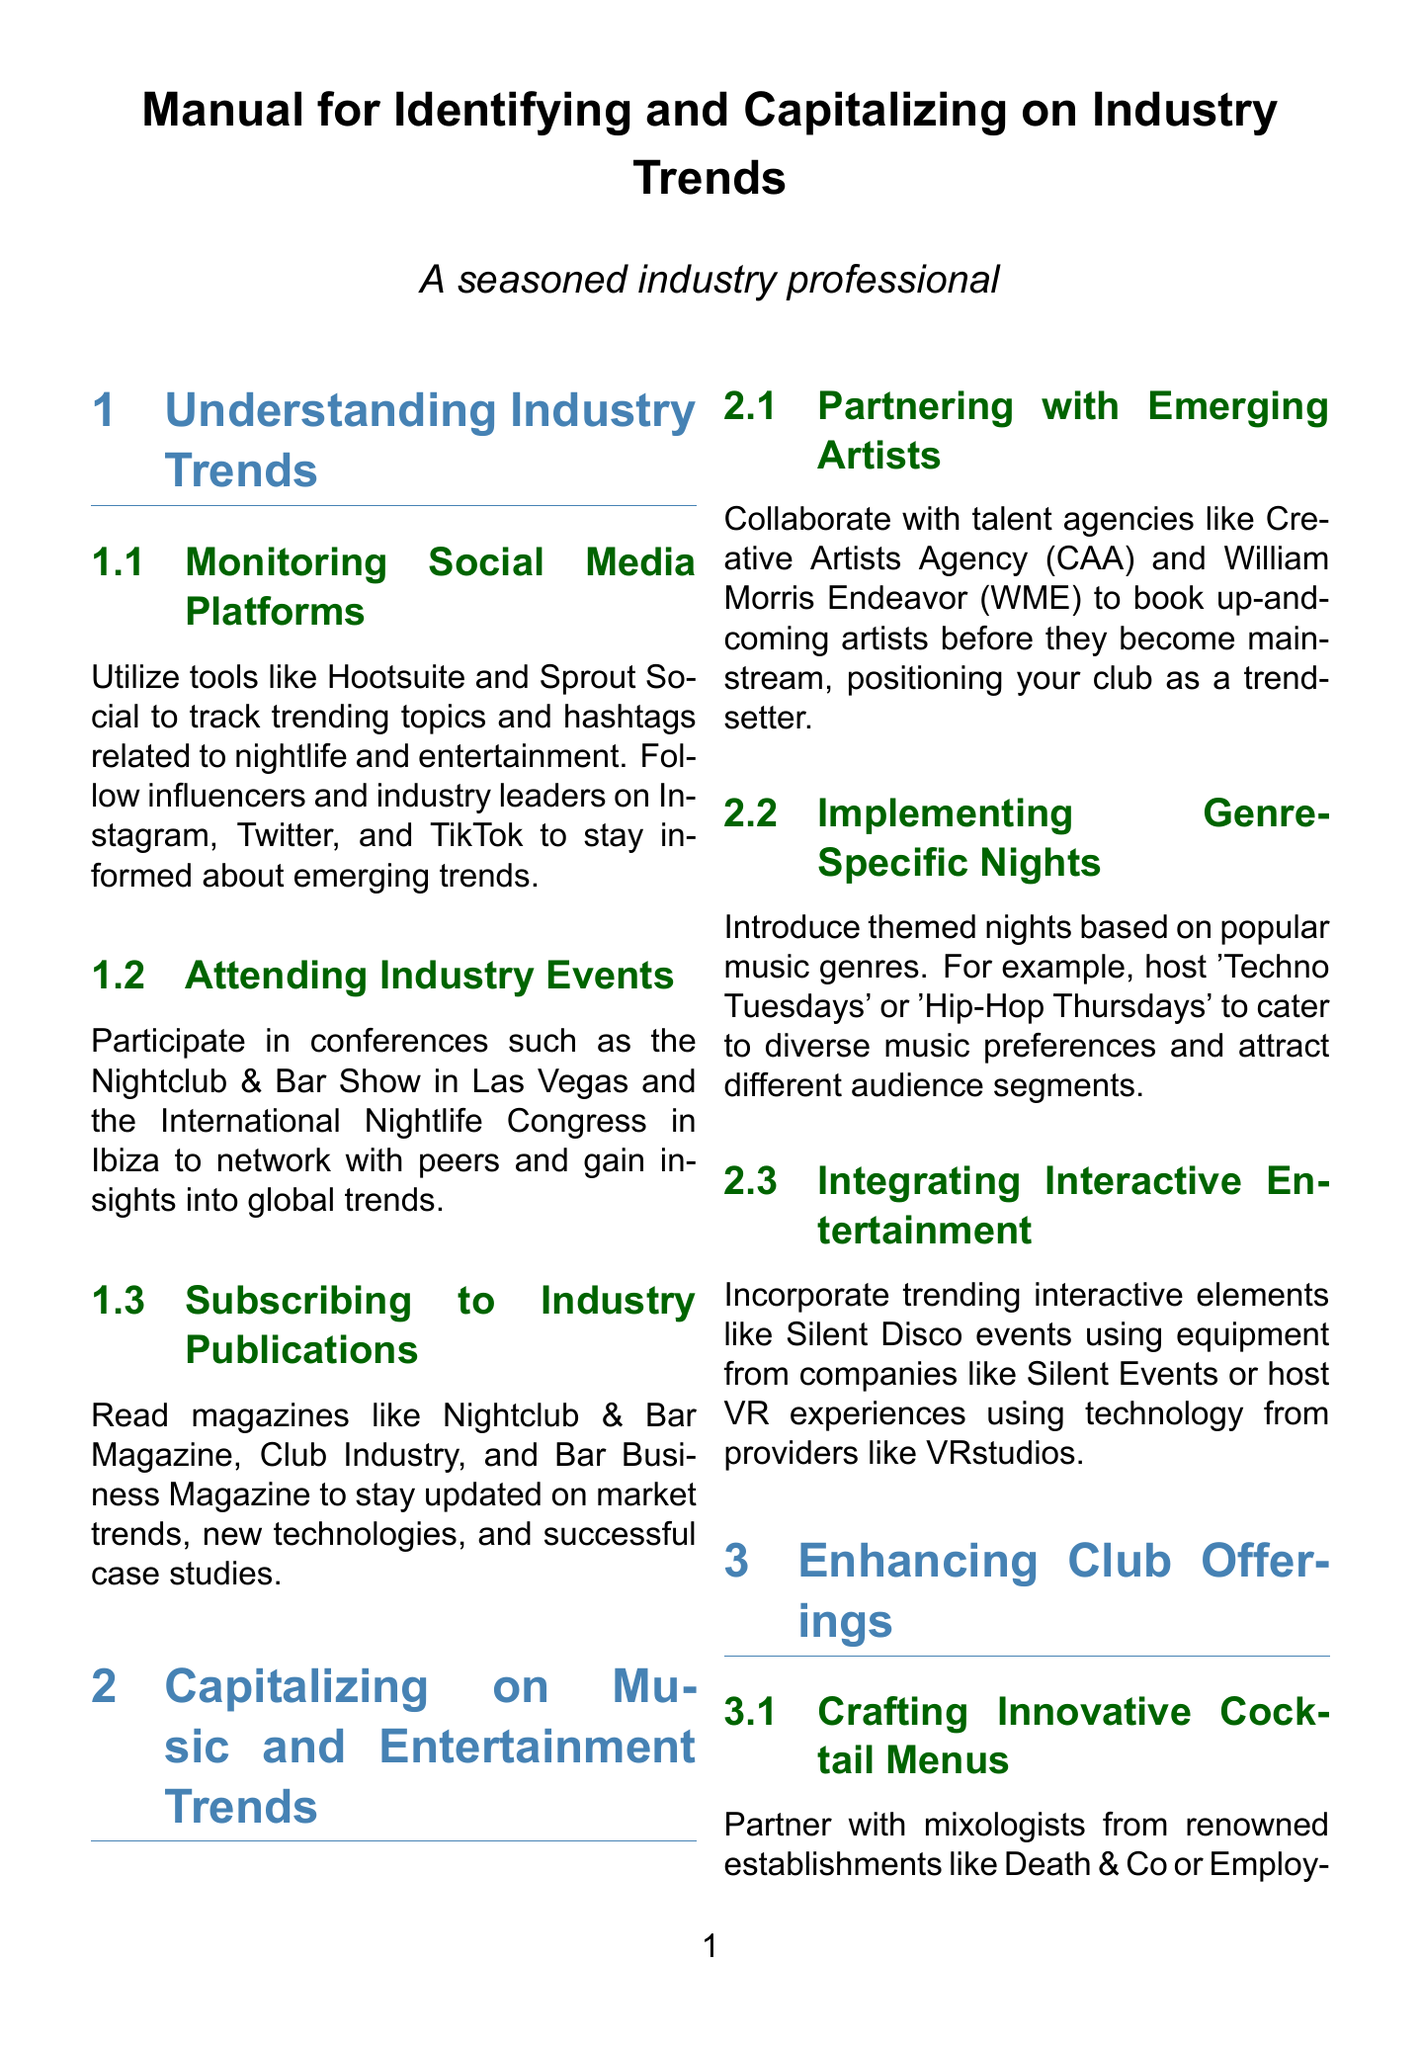What tools are suggested for monitoring social media trends? The manual suggests utilizing tools like Hootsuite and Sprout Social.
Answer: Hootsuite and Sprout Social What is one of the conferences mentioned for industry networking? The manual mentions the Nightclub & Bar Show in Las Vegas as one such conference.
Answer: Nightclub & Bar Show Which technology can be integrated for seamless payments? The manual recommends integrating RFID wristbands for this purpose.
Answer: RFID wristbands What is a recommended way to attract diverse clientele? The document states that hosting inclusive events can attract diverse clientele.
Answer: Hosting inclusive events Which marketing platform is suggested for creating targeted campaigns? The manual suggests using data-driven marketing platforms like Sprinklr or Salesforce Marketing Cloud.
Answer: Sprinklr or Salesforce Marketing Cloud What type of nights should be introduced to cater to diverse music preferences? The document recommends implementing genre-specific nights such as 'Techno Tuesdays' or 'Hip-Hop Thursdays'.
Answer: Genre-specific nights Which firms can be partnered with for organizing focus groups? Nielsen or Ipsos are mentioned as firms for organizing focus groups.
Answer: Nielsen or Ipsos What is the objective of subscribing to industry publications? The manual indicates that subscribing helps to stay updated on market trends.
Answer: Stay updated on market trends 